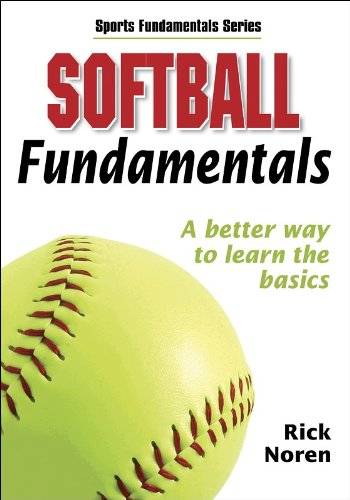Can you describe the key skills covered in this softball book? This book covers a range of essential softball skills such as batting techniques, fielding positions, and pitching strategies, aiming to enhance both beginners' and intermediate players' understanding of the game. 